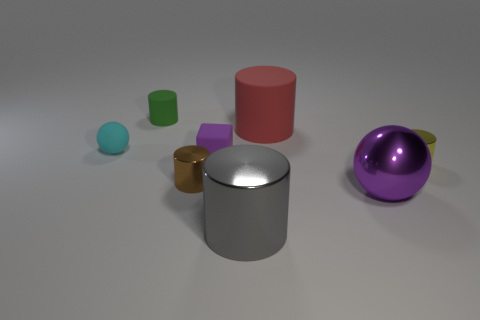What number of things are either big red metallic blocks or gray cylinders?
Your response must be concise. 1. There is a rubber cylinder that is the same size as the brown metallic object; what color is it?
Your answer should be compact. Green. How many objects are either large objects in front of the tiny yellow metallic cylinder or small yellow objects?
Provide a short and direct response. 3. How many other things are there of the same size as the gray cylinder?
Give a very brief answer. 2. There is a ball on the left side of the large red thing; what size is it?
Offer a terse response. Small. What is the shape of the small cyan object that is made of the same material as the tiny purple object?
Your answer should be compact. Sphere. Is there anything else that is the same color as the big shiny sphere?
Your answer should be very brief. Yes. There is a shiny cylinder that is to the right of the big cylinder that is in front of the red matte cylinder; what is its color?
Ensure brevity in your answer.  Yellow. What number of big objects are cyan rubber spheres or brown cylinders?
Your response must be concise. 0. There is another object that is the same shape as the purple metal thing; what material is it?
Provide a succinct answer. Rubber. 